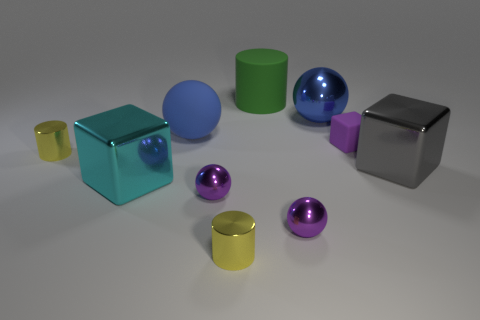Subtract 1 balls. How many balls are left? 3 Subtract all green balls. Subtract all brown cylinders. How many balls are left? 4 Subtract all cubes. How many objects are left? 7 Add 8 big cyan shiny objects. How many big cyan shiny objects are left? 9 Add 6 big gray cubes. How many big gray cubes exist? 7 Subtract 0 yellow balls. How many objects are left? 10 Subtract all blue matte balls. Subtract all big blue things. How many objects are left? 7 